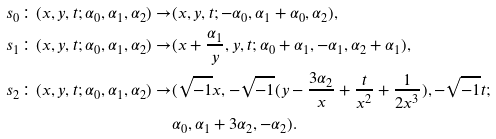<formula> <loc_0><loc_0><loc_500><loc_500>s _ { 0 } \colon ( x , y , t ; \alpha _ { 0 } , \alpha _ { 1 } , \alpha _ { 2 } ) \rightarrow & ( x , y , t ; - \alpha _ { 0 } , \alpha _ { 1 } + \alpha _ { 0 } , \alpha _ { 2 } ) , \\ s _ { 1 } \colon ( x , y , t ; \alpha _ { 0 } , \alpha _ { 1 } , \alpha _ { 2 } ) \rightarrow & ( x + \frac { \alpha _ { 1 } } { y } , y , t ; \alpha _ { 0 } + \alpha _ { 1 } , - \alpha _ { 1 } , \alpha _ { 2 } + \alpha _ { 1 } ) , \\ s _ { 2 } \colon ( x , y , t ; \alpha _ { 0 } , \alpha _ { 1 } , \alpha _ { 2 } ) \rightarrow & ( \sqrt { - 1 } x , - \sqrt { - 1 } ( y - \frac { 3 \alpha _ { 2 } } { x } + \frac { t } { x ^ { 2 } } + \frac { 1 } { 2 x ^ { 3 } } ) , - \sqrt { - 1 } t ; \\ & \alpha _ { 0 } , \alpha _ { 1 } + 3 \alpha _ { 2 } , - \alpha _ { 2 } ) .</formula> 